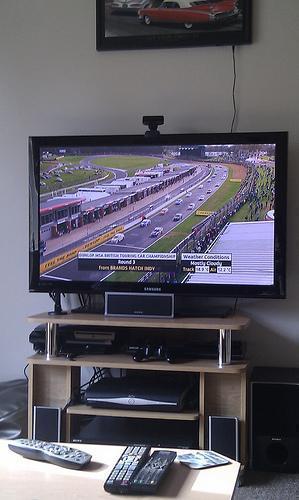How many TVs are shown?
Give a very brief answer. 1. How many remotes are shown?
Give a very brief answer. 3. How many all black remote controls are there?
Give a very brief answer. 2. 